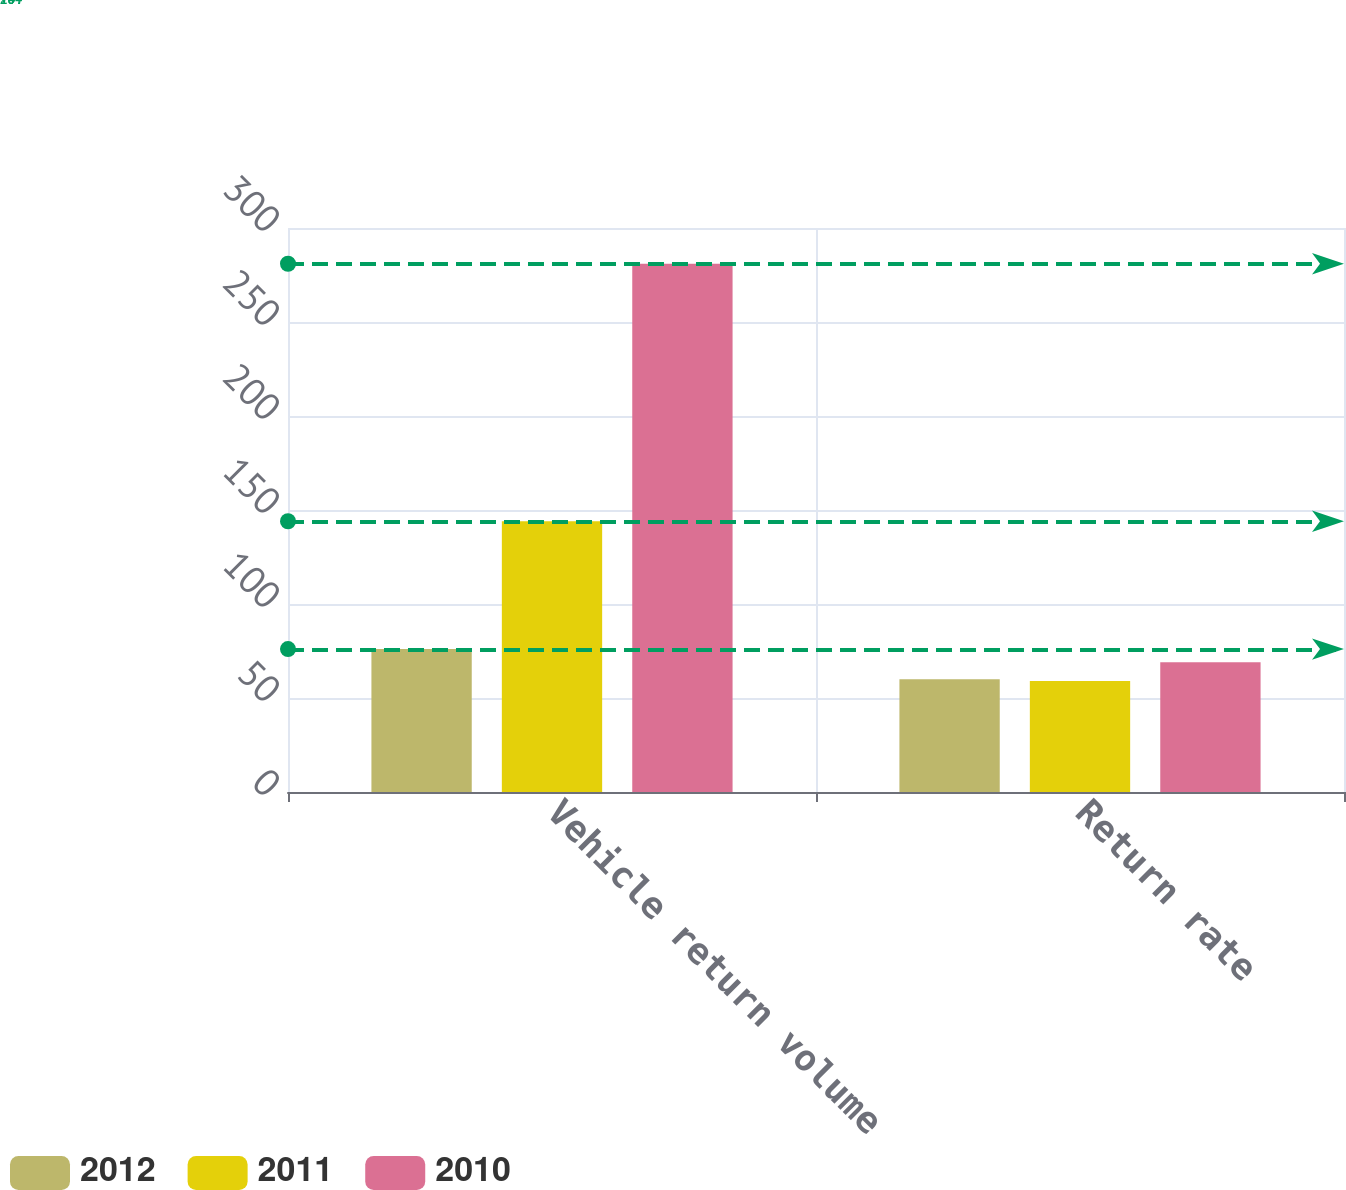Convert chart. <chart><loc_0><loc_0><loc_500><loc_500><stacked_bar_chart><ecel><fcel>Vehicle return volume<fcel>Return rate<nl><fcel>2012<fcel>76<fcel>60<nl><fcel>2011<fcel>144<fcel>59<nl><fcel>2010<fcel>281<fcel>69<nl></chart> 